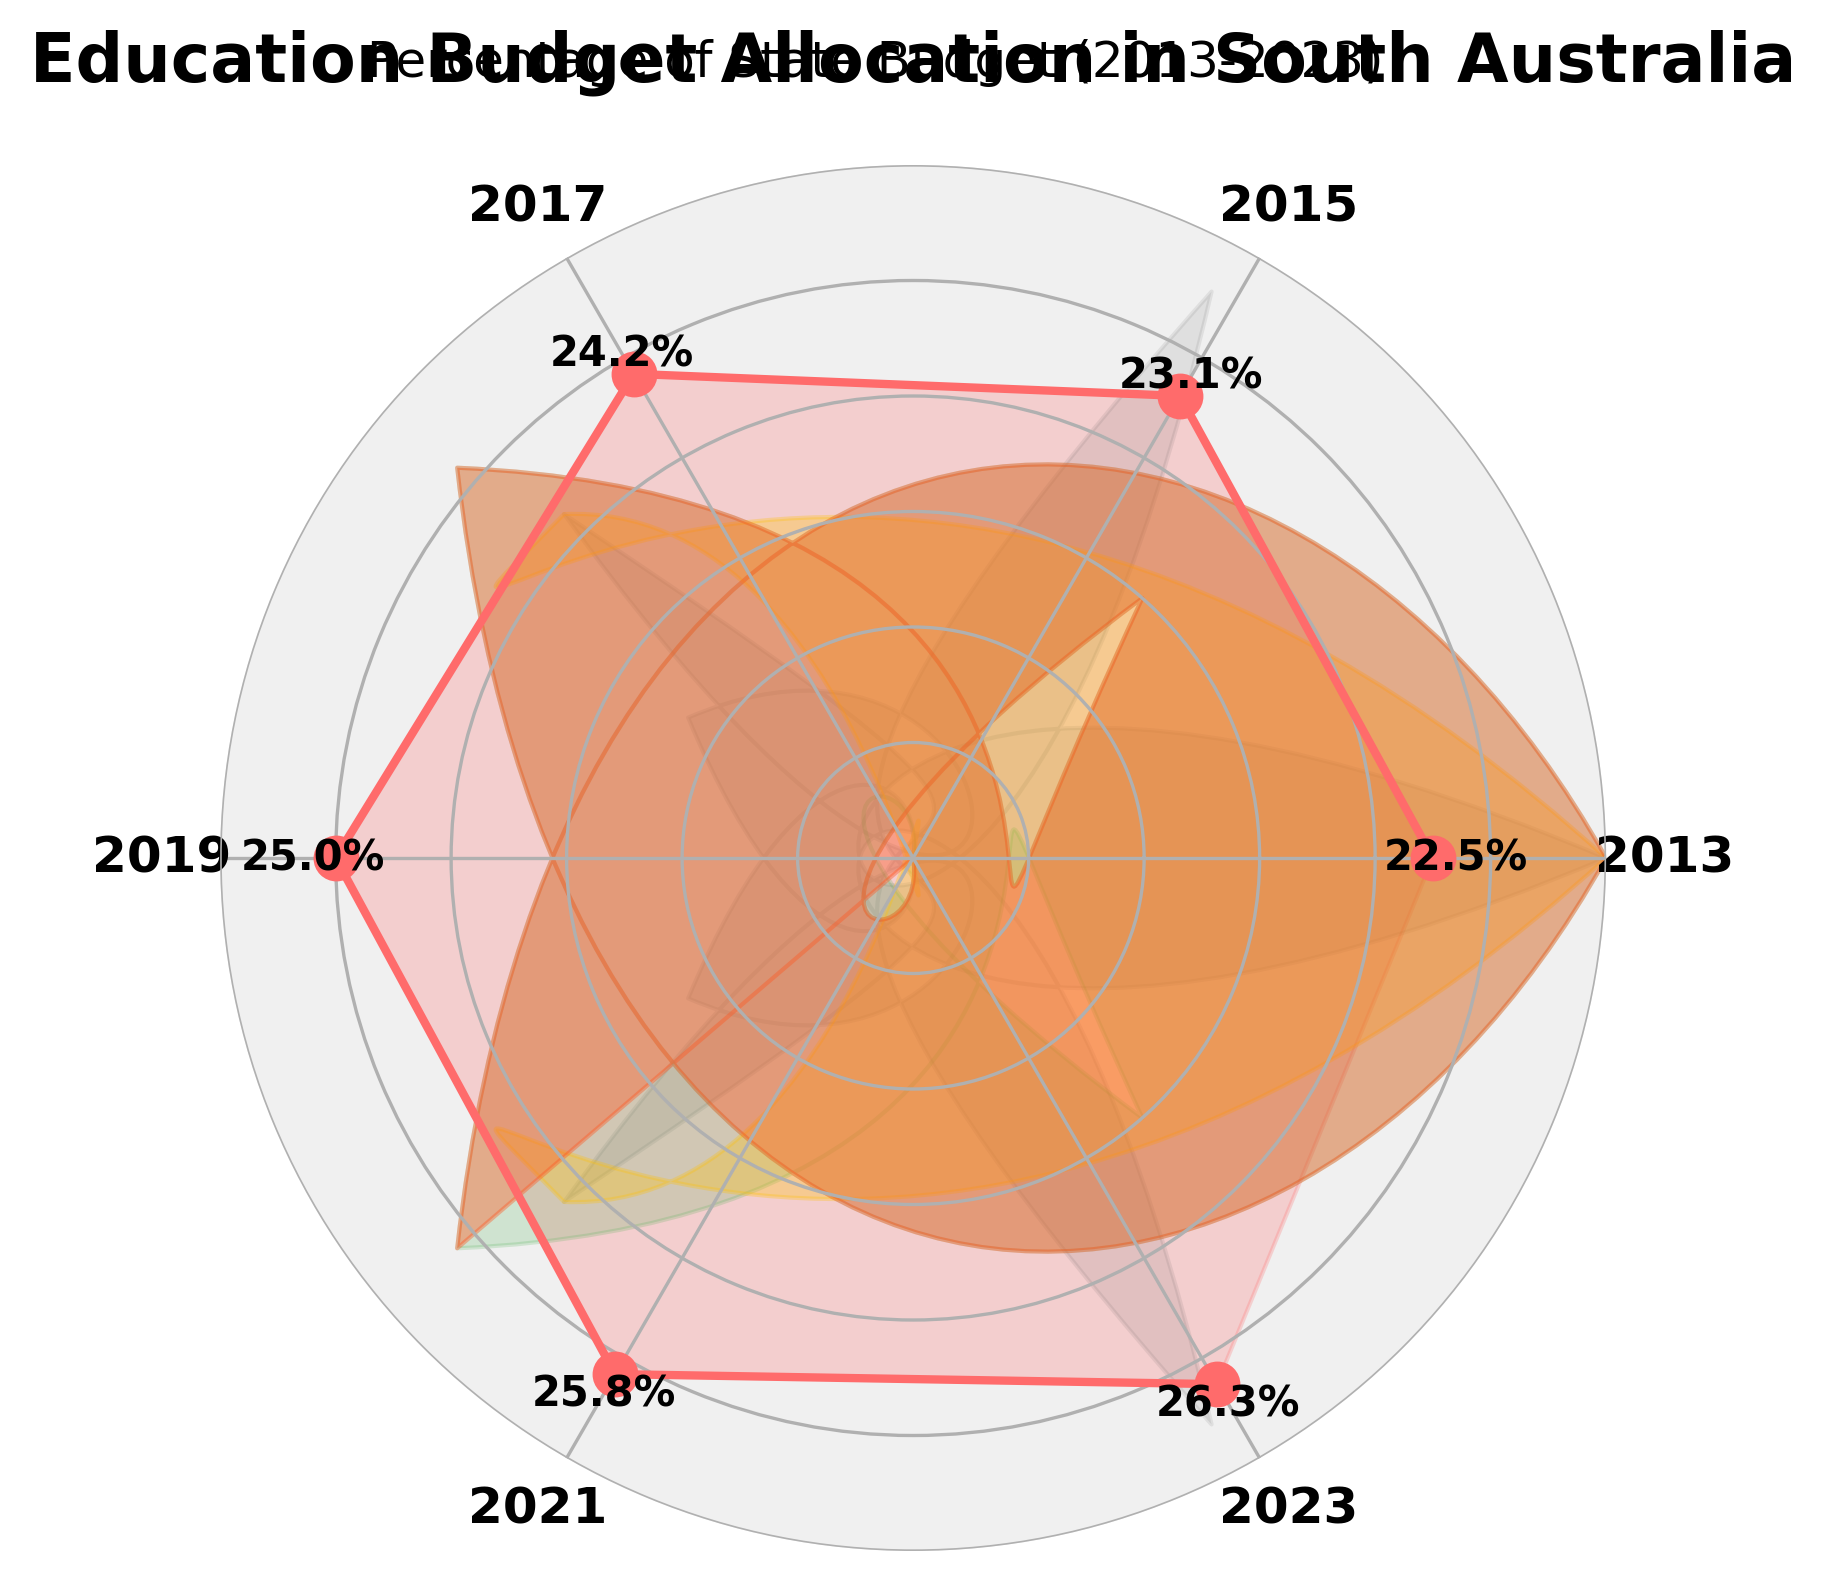what is the percentage of the South Australian state budget allocated to education in 2017? The gauge chart shows values for each specified year. Locate the point corresponding to 2017 and read the percentage next to it.
Answer: 24.2% how much did the education budget percentage increase from 2013 to 2023? Identify the percentage values for 2013 and 2023, which are 22.5% and 26.3%, respectively. Subtract the 2013 value from the 2023 value: 26.3% - 22.5% = 3.8%.
Answer: 3.8% which year had the highest education budget allocation percentage? Review the values at the different data points and identify the highest one, which corresponds to 2023 at 26.3%.
Answer: 2023 what is the average percentage of the education budget from 2013 to 2023? Sum the percentages for all the years and divide by the number of years: (22.5 + 23.1 + 24.2 + 25.0 + 25.8 + 26.3) / 6 = 24.48%.
Answer: 24.48% has the education budget allocation percentage increased or decreased over the decade? By comparing the values from 2013 (22.5%) to 2023 (26.3%), it is evident that the budget allocation has increased.
Answer: increased what is the median value of the education budget percentage from 2013 to 2023? First, sort the values from 2013 to 2023: [22.5, 23.1, 24.2, 25.0, 25.8, 26.3]. Since there is an even number of data points, the median is the average of the 3rd and 4th values: (24.2 + 25.0) / 2 = 24.6%.
Answer: 24.6% how does the budget allocation percentage in 2019 compare to that in 2021? Identify the values for 2019 and 2021, which are 25.0% and 25.8%, respectively. The percentage in 2021 is higher.
Answer: 2021 is higher which sector, based on the color segments, represents a higher percentage allocation in the range 25%-30%? In the gauge, the sector colored with a higher saturation and darker shade (red) indicates the higher percentage allocation in the 25%-30% range.
Answer: 25%-30% how much did the budget allocation percentage change between the two years with the smallest increase? Identify years with the smallest increase, which are 2017 (24.2%) and 2019 (25.0%). The change is 25.0% - 24.2% = 0.8%.
Answer: 0.8% what is the color indication for an education budget percentage around 23%? The colors assigned to different percentage ranges indicate that around 23%, a lighter sector (greenish-yellow) is present on the gauge chart.
Answer: greenish-yellow 